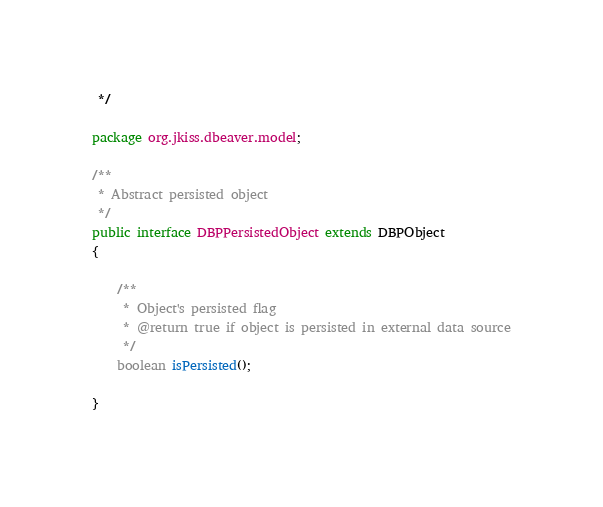Convert code to text. <code><loc_0><loc_0><loc_500><loc_500><_Java_> */

package org.jkiss.dbeaver.model;

/**
 * Abstract persisted object
 */
public interface DBPPersistedObject extends DBPObject
{

    /**
     * Object's persisted flag
     * @return true if object is persisted in external data source
     */
    boolean isPersisted();

}</code> 